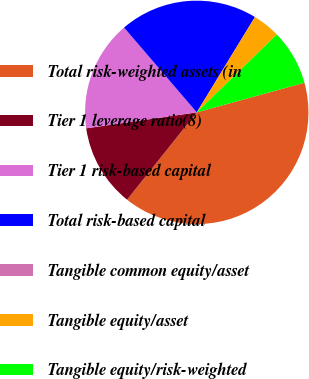Convert chart to OTSL. <chart><loc_0><loc_0><loc_500><loc_500><pie_chart><fcel>Total risk-weighted assets (in<fcel>Tier 1 leverage ratio(8)<fcel>Tier 1 risk-based capital<fcel>Total risk-based capital<fcel>Tangible common equity/asset<fcel>Tangible equity/asset<fcel>Tangible equity/risk-weighted<nl><fcel>39.99%<fcel>12.0%<fcel>16.0%<fcel>20.0%<fcel>0.0%<fcel>4.0%<fcel>8.0%<nl></chart> 